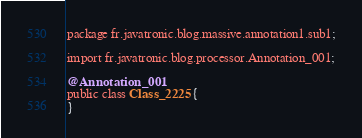Convert code to text. <code><loc_0><loc_0><loc_500><loc_500><_Java_>package fr.javatronic.blog.massive.annotation1.sub1;

import fr.javatronic.blog.processor.Annotation_001;

@Annotation_001
public class Class_2225 {
}
</code> 